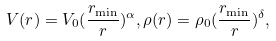Convert formula to latex. <formula><loc_0><loc_0><loc_500><loc_500>V ( r ) = V _ { 0 } ( \frac { r _ { \min } } { r } ) ^ { \alpha } , \rho ( r ) = \rho _ { 0 } ( \frac { r _ { \min } } { r } ) ^ { \delta } ,</formula> 